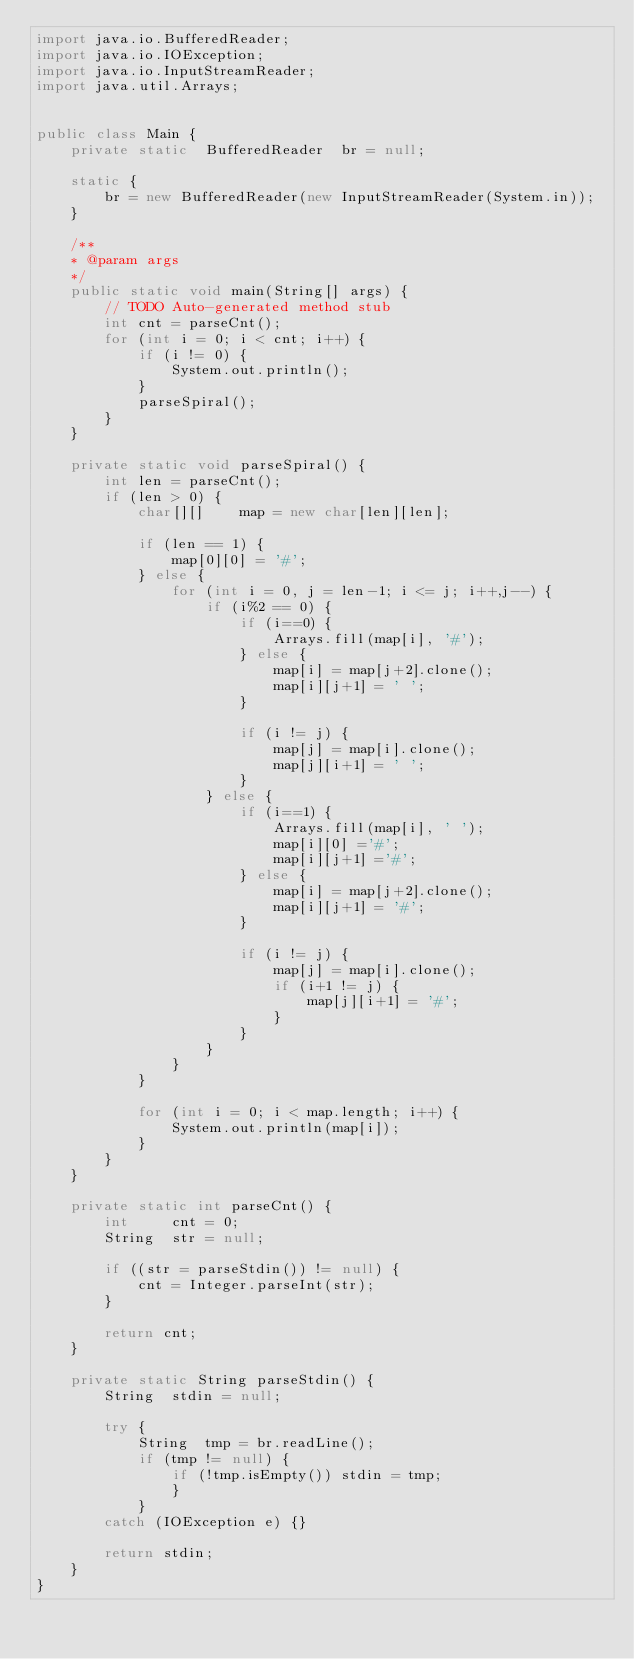Convert code to text. <code><loc_0><loc_0><loc_500><loc_500><_Java_>import java.io.BufferedReader;
import java.io.IOException;
import java.io.InputStreamReader;
import java.util.Arrays;
 
 
public class Main {
	private static  BufferedReader  br = null;

	static {
		br = new BufferedReader(new InputStreamReader(System.in));
	}

	/**
	* @param args
	*/
	public static void main(String[] args) {
		// TODO Auto-generated method stub
		int cnt = parseCnt();
		for (int i = 0; i < cnt; i++) {
			if (i != 0) {
				System.out.println();
			}
			parseSpiral();
		}
	}

	private static void parseSpiral() {
		int	len = parseCnt();
		if (len > 0) {
			char[][]	map = new char[len][len];

			if (len == 1) {
				map[0][0] = '#';
			} else {
				for (int i = 0, j = len-1; i <= j; i++,j--) {
					if (i%2 == 0) {
						if (i==0) {
							Arrays.fill(map[i], '#');
						} else {
							map[i] = map[j+2].clone();
							map[i][j+1] = ' ';
						}

						if (i != j) {
							map[j] = map[i].clone();
							map[j][i+1] = ' ';
						}
					} else {
						if (i==1) {
							Arrays.fill(map[i], ' ');
							map[i][0] ='#';
							map[i][j+1] ='#';
						} else {
							map[i] = map[j+2].clone();
							map[i][j+1] = '#';
						}

						if (i != j) {
							map[j] = map[i].clone();
							if (i+1 != j) {
								map[j][i+1] = '#';
							}
						}
					}
				}
			}

			for (int i = 0; i < map.length; i++) {
				System.out.println(map[i]);
			}
		}
	}

	private static int parseCnt() {
		int     cnt = 0;
		String  str = null;

		if ((str = parseStdin()) != null) {
			cnt = Integer.parseInt(str);
		}

		return cnt;
	}

	private static String parseStdin() {
		String	stdin = null;

		try {
			String	tmp = br.readLine();
			if (tmp != null) {
				if (!tmp.isEmpty()) stdin = tmp;
				}
			}
		catch (IOException e) {}

		return stdin;
	}
}</code> 